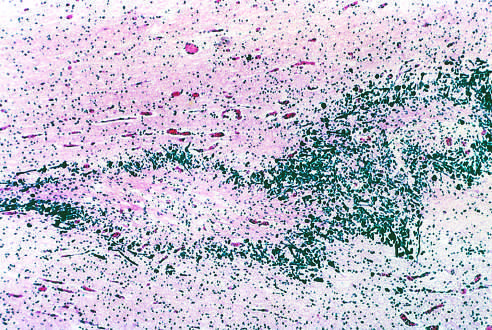what contains a central focus of white matter necrosis with a peripheral rim of mineralized axonal processes?
Answer the question using a single word or phrase. This specimen from a patient with periventricular leukomalacia 